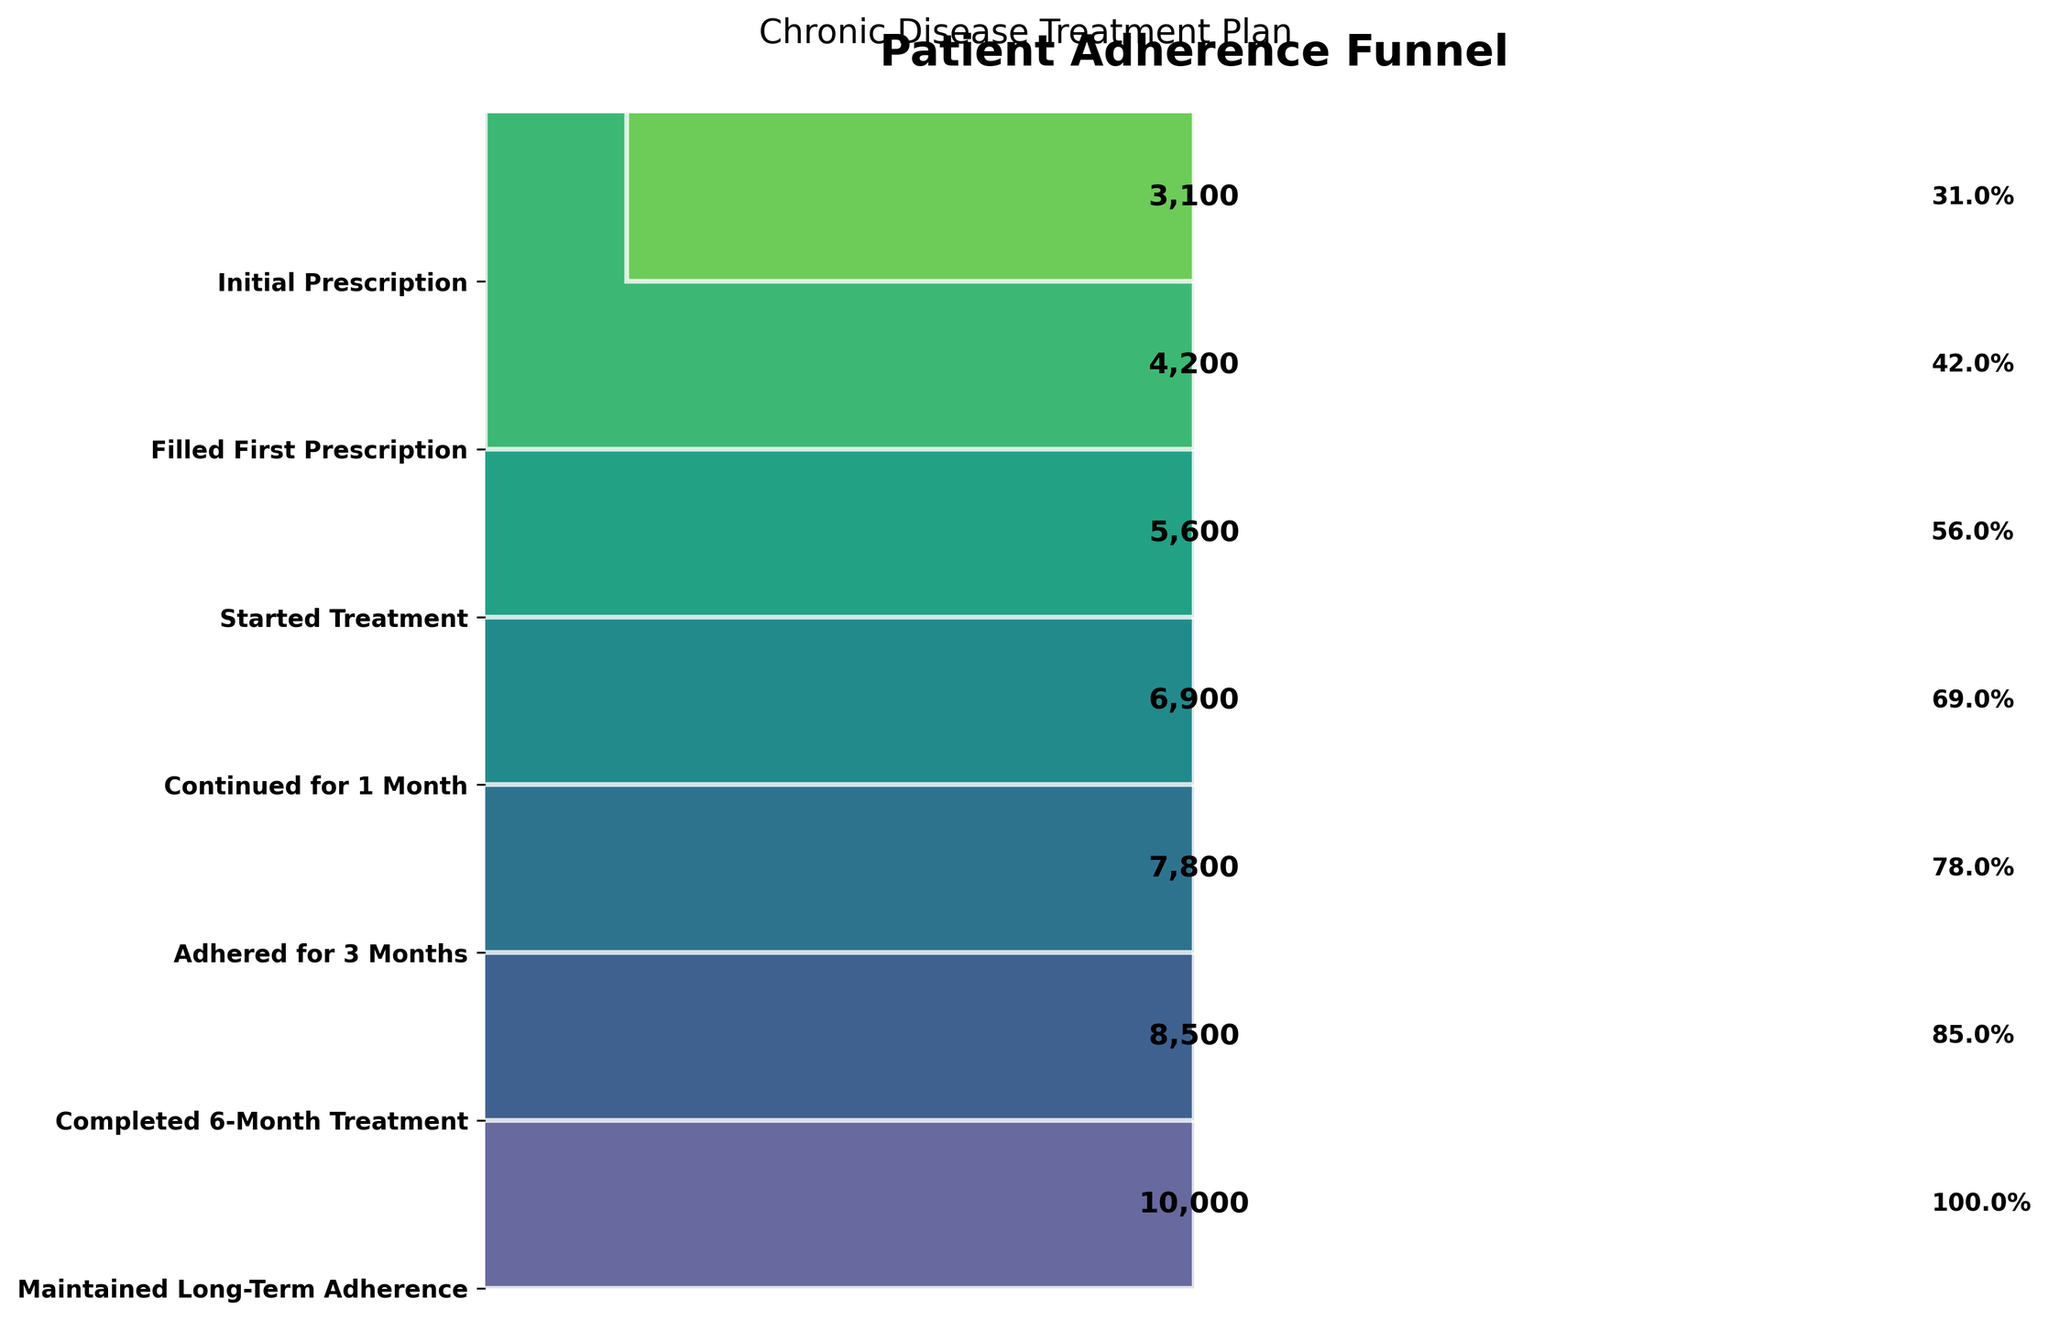what is the title of the funnel chart? The title is often the most prominent text at the top of the chart. In this case, it is "Patient Adherence Funnel" and "Chronic Disease Treatment Plan" as a subtitle.
Answer: Patient Adherence Funnel How many stages are represented in the funnel chart? By looking at the y-axis, we can count the number of different stages listed. Each stage corresponds to a bar. There are 7 stages shown: Initial Prescription, Filled First Prescription, Started Treatment, Continued for 1 Month, Adhered for 3 Months, Completed 6-Month Treatment, and Maintained Long-Term Adherence.
Answer: 7 How many patients adhered to the treatment for 3 months? Check the value labeled next to "Adhered for 3 Months" on the y-axis, which shows the patient count at this stage. The count next to this stage is 5600.
Answer: 5600 Which stage shows the highest dropout in patient adherence? To find the stage with the highest dropout, look for the stage with the largest difference in patient count compared to the previous stage. The largest drop is between "Adhered for 3 Months" (5600) and "Completed 6-Month Treatment" (4200), a difference of 1400.
Answer: Adhered for 3 Months to Completed 6-Month Treatment What percentage of patients who started treatment completed the 6-month treatment plan? Find the number of patients who started treatment (7800) and those who completed the 6-month treatment (4200). The percentage can be calculated as (4200 / 7800) * 100 = 53.8%.
Answer: 53.8% What are the number of patients who discontinued the treatment after 1 month? To find this, subtract the number of patients who adhered for 3 months (5600) from those who continued for 1 month (6900). 6900 - 5600 = 1300.
Answer: 1300 How many patients maintained long-term adherence out of those who got an Initial Prescription? The number of patients who maintained long-term adherence is shown as 3100 and the number of patients who got an initial prescription is 10000. To get the count directly, it is 3100.
Answer: 3100 Compare the patient numbers between the stages "Started Treatment" and "Maintained Long-Term Adherence". Which stage has more patients and by how much? Compare the numbers: 7800 patients started treatment, and 3100 maintained long-term adherence. The difference is 7800 - 3100 = 4700. The "Started Treatment" stage has more patients.
Answer: Started Treatment, 4700 more 